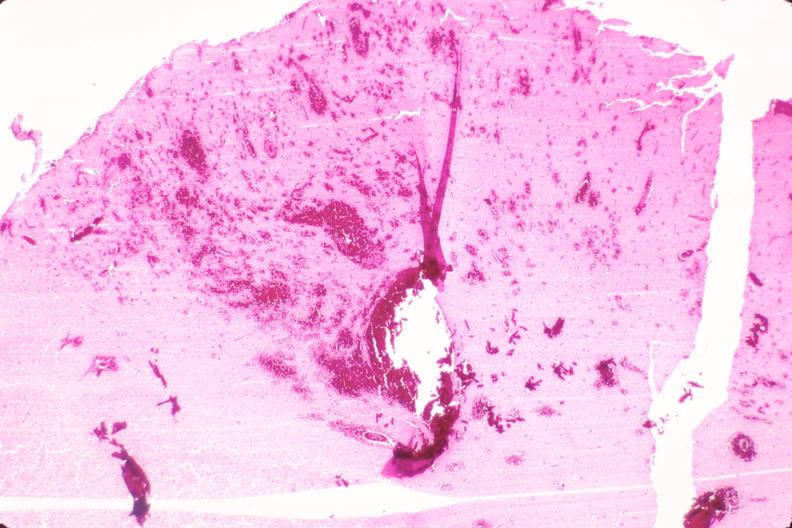what does this image show?
Answer the question using a single word or phrase. Brain 